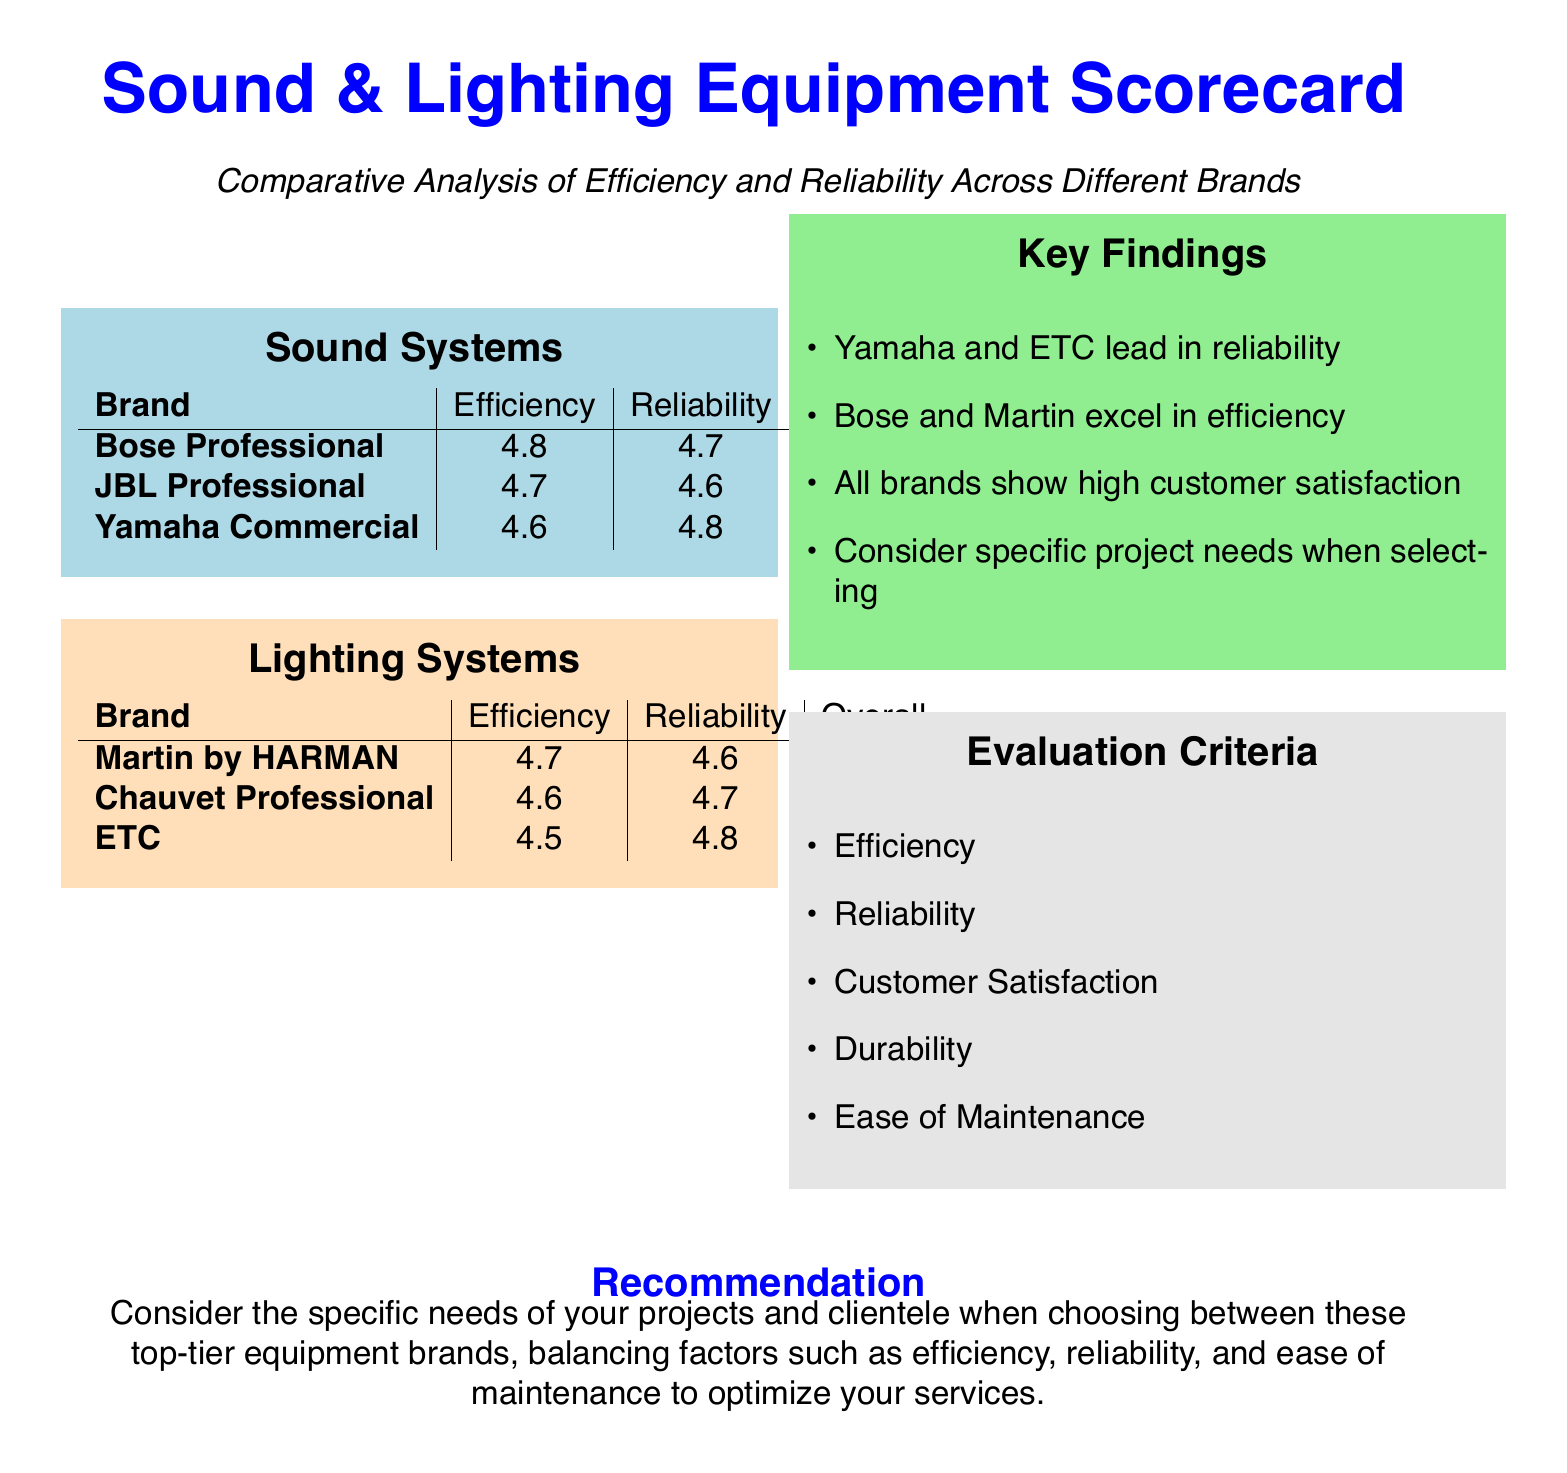What is the overall rating for Bose Professional? The overall rating for Bose Professional is stated in the table under Sound Systems.
Answer: 4.7 Which brand of sound systems has the highest efficiency rating? The highest efficiency rating is noted in the Efficiency column under Sound Systems.
Answer: Bose Professional What is the reliability rating of ETC lighting systems? The reliability rating for ETC is found in the table for Lighting Systems.
Answer: 4.8 Which equipment brand is highlighted for excelling in efficiency? The commentary in the Key Findings section mentions which brands excel in efficiency.
Answer: Bose and Martin What is one of the evaluation criteria mentioned in the document? The Evaluation Criteria section lists multiple criteria used for assessing the equipment.
Answer: Efficiency Which sound system brand shows the second-highest reliability? The reliability ratings in the Sound Systems table help determine the ranking of the brands.
Answer: Yamaha Commercial Which brand is recommended for consideration based on project needs? The recommendation section suggests considering project needs when choosing brands.
Answer: All brands 